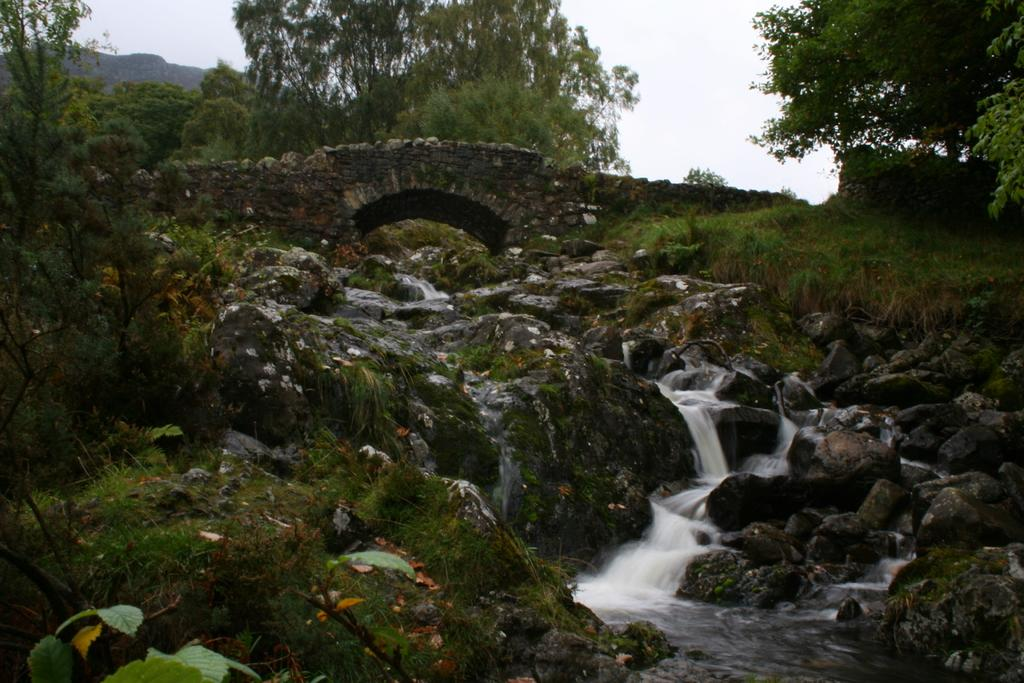What is the primary element visible in the image? There is water in the image. What structure can be seen behind the water? There is a stone bridge behind the water. What type of vegetation is visible in the background of the image? There are trees in the background of the image. What type of road can be seen in the image? There is no road visible in the image; it primarily features water, a stone bridge, and trees in the background. 